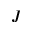Convert formula to latex. <formula><loc_0><loc_0><loc_500><loc_500>J</formula> 